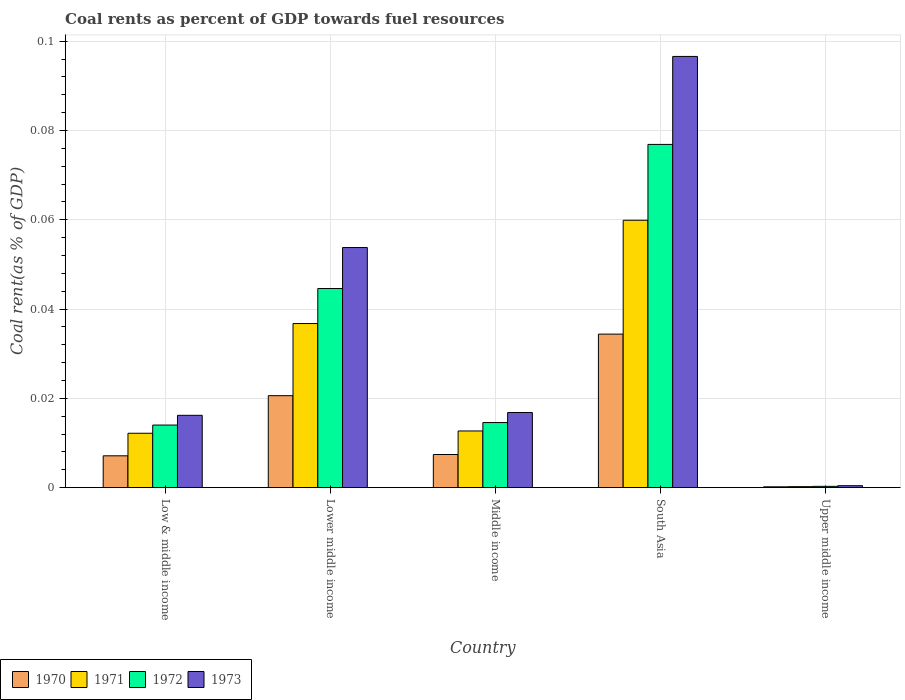How many different coloured bars are there?
Make the answer very short. 4. How many groups of bars are there?
Keep it short and to the point. 5. Are the number of bars on each tick of the X-axis equal?
Keep it short and to the point. Yes. How many bars are there on the 5th tick from the left?
Your answer should be very brief. 4. What is the label of the 5th group of bars from the left?
Keep it short and to the point. Upper middle income. What is the coal rent in 1972 in Middle income?
Ensure brevity in your answer.  0.01. Across all countries, what is the maximum coal rent in 1971?
Your response must be concise. 0.06. Across all countries, what is the minimum coal rent in 1973?
Provide a short and direct response. 0. In which country was the coal rent in 1972 maximum?
Provide a succinct answer. South Asia. In which country was the coal rent in 1970 minimum?
Keep it short and to the point. Upper middle income. What is the total coal rent in 1973 in the graph?
Your answer should be very brief. 0.18. What is the difference between the coal rent in 1971 in Low & middle income and that in Lower middle income?
Your response must be concise. -0.02. What is the difference between the coal rent in 1973 in Low & middle income and the coal rent in 1970 in Upper middle income?
Your answer should be very brief. 0.02. What is the average coal rent in 1972 per country?
Give a very brief answer. 0.03. What is the difference between the coal rent of/in 1970 and coal rent of/in 1973 in Lower middle income?
Provide a short and direct response. -0.03. In how many countries, is the coal rent in 1972 greater than 0.068 %?
Ensure brevity in your answer.  1. What is the ratio of the coal rent in 1970 in Low & middle income to that in South Asia?
Offer a very short reply. 0.21. Is the coal rent in 1971 in Middle income less than that in Upper middle income?
Offer a very short reply. No. What is the difference between the highest and the second highest coal rent in 1971?
Your answer should be very brief. 0.05. What is the difference between the highest and the lowest coal rent in 1973?
Give a very brief answer. 0.1. In how many countries, is the coal rent in 1970 greater than the average coal rent in 1970 taken over all countries?
Offer a terse response. 2. Is the sum of the coal rent in 1970 in Low & middle income and Middle income greater than the maximum coal rent in 1972 across all countries?
Provide a succinct answer. No. Is it the case that in every country, the sum of the coal rent in 1971 and coal rent in 1970 is greater than the sum of coal rent in 1972 and coal rent in 1973?
Provide a succinct answer. No. What does the 4th bar from the left in South Asia represents?
Provide a succinct answer. 1973. What does the 4th bar from the right in Upper middle income represents?
Your answer should be compact. 1970. Is it the case that in every country, the sum of the coal rent in 1971 and coal rent in 1973 is greater than the coal rent in 1972?
Give a very brief answer. Yes. How many bars are there?
Your response must be concise. 20. How many countries are there in the graph?
Keep it short and to the point. 5. Does the graph contain any zero values?
Give a very brief answer. No. Does the graph contain grids?
Offer a very short reply. Yes. Where does the legend appear in the graph?
Provide a short and direct response. Bottom left. How many legend labels are there?
Your response must be concise. 4. What is the title of the graph?
Ensure brevity in your answer.  Coal rents as percent of GDP towards fuel resources. Does "1977" appear as one of the legend labels in the graph?
Offer a terse response. No. What is the label or title of the X-axis?
Provide a short and direct response. Country. What is the label or title of the Y-axis?
Give a very brief answer. Coal rent(as % of GDP). What is the Coal rent(as % of GDP) in 1970 in Low & middle income?
Your answer should be very brief. 0.01. What is the Coal rent(as % of GDP) of 1971 in Low & middle income?
Offer a very short reply. 0.01. What is the Coal rent(as % of GDP) in 1972 in Low & middle income?
Offer a very short reply. 0.01. What is the Coal rent(as % of GDP) in 1973 in Low & middle income?
Offer a terse response. 0.02. What is the Coal rent(as % of GDP) in 1970 in Lower middle income?
Give a very brief answer. 0.02. What is the Coal rent(as % of GDP) of 1971 in Lower middle income?
Your response must be concise. 0.04. What is the Coal rent(as % of GDP) of 1972 in Lower middle income?
Ensure brevity in your answer.  0.04. What is the Coal rent(as % of GDP) in 1973 in Lower middle income?
Keep it short and to the point. 0.05. What is the Coal rent(as % of GDP) in 1970 in Middle income?
Offer a very short reply. 0.01. What is the Coal rent(as % of GDP) in 1971 in Middle income?
Give a very brief answer. 0.01. What is the Coal rent(as % of GDP) in 1972 in Middle income?
Provide a short and direct response. 0.01. What is the Coal rent(as % of GDP) in 1973 in Middle income?
Provide a short and direct response. 0.02. What is the Coal rent(as % of GDP) in 1970 in South Asia?
Give a very brief answer. 0.03. What is the Coal rent(as % of GDP) of 1971 in South Asia?
Provide a short and direct response. 0.06. What is the Coal rent(as % of GDP) of 1972 in South Asia?
Offer a terse response. 0.08. What is the Coal rent(as % of GDP) of 1973 in South Asia?
Your response must be concise. 0.1. What is the Coal rent(as % of GDP) of 1970 in Upper middle income?
Your response must be concise. 0. What is the Coal rent(as % of GDP) of 1971 in Upper middle income?
Your answer should be very brief. 0. What is the Coal rent(as % of GDP) in 1972 in Upper middle income?
Your answer should be very brief. 0. What is the Coal rent(as % of GDP) of 1973 in Upper middle income?
Make the answer very short. 0. Across all countries, what is the maximum Coal rent(as % of GDP) in 1970?
Provide a succinct answer. 0.03. Across all countries, what is the maximum Coal rent(as % of GDP) in 1971?
Your answer should be compact. 0.06. Across all countries, what is the maximum Coal rent(as % of GDP) of 1972?
Offer a very short reply. 0.08. Across all countries, what is the maximum Coal rent(as % of GDP) of 1973?
Your answer should be compact. 0.1. Across all countries, what is the minimum Coal rent(as % of GDP) in 1970?
Provide a succinct answer. 0. Across all countries, what is the minimum Coal rent(as % of GDP) of 1971?
Make the answer very short. 0. Across all countries, what is the minimum Coal rent(as % of GDP) of 1972?
Keep it short and to the point. 0. Across all countries, what is the minimum Coal rent(as % of GDP) in 1973?
Your response must be concise. 0. What is the total Coal rent(as % of GDP) of 1970 in the graph?
Offer a terse response. 0.07. What is the total Coal rent(as % of GDP) of 1971 in the graph?
Ensure brevity in your answer.  0.12. What is the total Coal rent(as % of GDP) of 1972 in the graph?
Give a very brief answer. 0.15. What is the total Coal rent(as % of GDP) of 1973 in the graph?
Provide a succinct answer. 0.18. What is the difference between the Coal rent(as % of GDP) in 1970 in Low & middle income and that in Lower middle income?
Provide a short and direct response. -0.01. What is the difference between the Coal rent(as % of GDP) in 1971 in Low & middle income and that in Lower middle income?
Provide a succinct answer. -0.02. What is the difference between the Coal rent(as % of GDP) of 1972 in Low & middle income and that in Lower middle income?
Provide a short and direct response. -0.03. What is the difference between the Coal rent(as % of GDP) in 1973 in Low & middle income and that in Lower middle income?
Offer a very short reply. -0.04. What is the difference between the Coal rent(as % of GDP) of 1970 in Low & middle income and that in Middle income?
Make the answer very short. -0. What is the difference between the Coal rent(as % of GDP) in 1971 in Low & middle income and that in Middle income?
Provide a succinct answer. -0. What is the difference between the Coal rent(as % of GDP) in 1972 in Low & middle income and that in Middle income?
Offer a terse response. -0. What is the difference between the Coal rent(as % of GDP) of 1973 in Low & middle income and that in Middle income?
Provide a short and direct response. -0. What is the difference between the Coal rent(as % of GDP) of 1970 in Low & middle income and that in South Asia?
Offer a very short reply. -0.03. What is the difference between the Coal rent(as % of GDP) in 1971 in Low & middle income and that in South Asia?
Keep it short and to the point. -0.05. What is the difference between the Coal rent(as % of GDP) in 1972 in Low & middle income and that in South Asia?
Your answer should be compact. -0.06. What is the difference between the Coal rent(as % of GDP) of 1973 in Low & middle income and that in South Asia?
Ensure brevity in your answer.  -0.08. What is the difference between the Coal rent(as % of GDP) of 1970 in Low & middle income and that in Upper middle income?
Make the answer very short. 0.01. What is the difference between the Coal rent(as % of GDP) of 1971 in Low & middle income and that in Upper middle income?
Make the answer very short. 0.01. What is the difference between the Coal rent(as % of GDP) in 1972 in Low & middle income and that in Upper middle income?
Ensure brevity in your answer.  0.01. What is the difference between the Coal rent(as % of GDP) in 1973 in Low & middle income and that in Upper middle income?
Offer a very short reply. 0.02. What is the difference between the Coal rent(as % of GDP) in 1970 in Lower middle income and that in Middle income?
Make the answer very short. 0.01. What is the difference between the Coal rent(as % of GDP) in 1971 in Lower middle income and that in Middle income?
Your answer should be compact. 0.02. What is the difference between the Coal rent(as % of GDP) of 1972 in Lower middle income and that in Middle income?
Your answer should be very brief. 0.03. What is the difference between the Coal rent(as % of GDP) of 1973 in Lower middle income and that in Middle income?
Your answer should be very brief. 0.04. What is the difference between the Coal rent(as % of GDP) of 1970 in Lower middle income and that in South Asia?
Keep it short and to the point. -0.01. What is the difference between the Coal rent(as % of GDP) of 1971 in Lower middle income and that in South Asia?
Make the answer very short. -0.02. What is the difference between the Coal rent(as % of GDP) in 1972 in Lower middle income and that in South Asia?
Provide a succinct answer. -0.03. What is the difference between the Coal rent(as % of GDP) in 1973 in Lower middle income and that in South Asia?
Your response must be concise. -0.04. What is the difference between the Coal rent(as % of GDP) of 1970 in Lower middle income and that in Upper middle income?
Ensure brevity in your answer.  0.02. What is the difference between the Coal rent(as % of GDP) in 1971 in Lower middle income and that in Upper middle income?
Give a very brief answer. 0.04. What is the difference between the Coal rent(as % of GDP) of 1972 in Lower middle income and that in Upper middle income?
Ensure brevity in your answer.  0.04. What is the difference between the Coal rent(as % of GDP) in 1973 in Lower middle income and that in Upper middle income?
Your answer should be compact. 0.05. What is the difference between the Coal rent(as % of GDP) of 1970 in Middle income and that in South Asia?
Provide a short and direct response. -0.03. What is the difference between the Coal rent(as % of GDP) of 1971 in Middle income and that in South Asia?
Your response must be concise. -0.05. What is the difference between the Coal rent(as % of GDP) in 1972 in Middle income and that in South Asia?
Provide a short and direct response. -0.06. What is the difference between the Coal rent(as % of GDP) of 1973 in Middle income and that in South Asia?
Give a very brief answer. -0.08. What is the difference between the Coal rent(as % of GDP) of 1970 in Middle income and that in Upper middle income?
Offer a very short reply. 0.01. What is the difference between the Coal rent(as % of GDP) of 1971 in Middle income and that in Upper middle income?
Your answer should be very brief. 0.01. What is the difference between the Coal rent(as % of GDP) in 1972 in Middle income and that in Upper middle income?
Offer a terse response. 0.01. What is the difference between the Coal rent(as % of GDP) of 1973 in Middle income and that in Upper middle income?
Make the answer very short. 0.02. What is the difference between the Coal rent(as % of GDP) in 1970 in South Asia and that in Upper middle income?
Offer a terse response. 0.03. What is the difference between the Coal rent(as % of GDP) of 1971 in South Asia and that in Upper middle income?
Make the answer very short. 0.06. What is the difference between the Coal rent(as % of GDP) of 1972 in South Asia and that in Upper middle income?
Your response must be concise. 0.08. What is the difference between the Coal rent(as % of GDP) in 1973 in South Asia and that in Upper middle income?
Provide a short and direct response. 0.1. What is the difference between the Coal rent(as % of GDP) in 1970 in Low & middle income and the Coal rent(as % of GDP) in 1971 in Lower middle income?
Provide a succinct answer. -0.03. What is the difference between the Coal rent(as % of GDP) of 1970 in Low & middle income and the Coal rent(as % of GDP) of 1972 in Lower middle income?
Give a very brief answer. -0.04. What is the difference between the Coal rent(as % of GDP) of 1970 in Low & middle income and the Coal rent(as % of GDP) of 1973 in Lower middle income?
Keep it short and to the point. -0.05. What is the difference between the Coal rent(as % of GDP) of 1971 in Low & middle income and the Coal rent(as % of GDP) of 1972 in Lower middle income?
Your answer should be very brief. -0.03. What is the difference between the Coal rent(as % of GDP) of 1971 in Low & middle income and the Coal rent(as % of GDP) of 1973 in Lower middle income?
Provide a succinct answer. -0.04. What is the difference between the Coal rent(as % of GDP) of 1972 in Low & middle income and the Coal rent(as % of GDP) of 1973 in Lower middle income?
Your response must be concise. -0.04. What is the difference between the Coal rent(as % of GDP) in 1970 in Low & middle income and the Coal rent(as % of GDP) in 1971 in Middle income?
Provide a short and direct response. -0.01. What is the difference between the Coal rent(as % of GDP) in 1970 in Low & middle income and the Coal rent(as % of GDP) in 1972 in Middle income?
Offer a very short reply. -0.01. What is the difference between the Coal rent(as % of GDP) of 1970 in Low & middle income and the Coal rent(as % of GDP) of 1973 in Middle income?
Your answer should be compact. -0.01. What is the difference between the Coal rent(as % of GDP) of 1971 in Low & middle income and the Coal rent(as % of GDP) of 1972 in Middle income?
Keep it short and to the point. -0. What is the difference between the Coal rent(as % of GDP) of 1971 in Low & middle income and the Coal rent(as % of GDP) of 1973 in Middle income?
Give a very brief answer. -0. What is the difference between the Coal rent(as % of GDP) of 1972 in Low & middle income and the Coal rent(as % of GDP) of 1973 in Middle income?
Your answer should be very brief. -0. What is the difference between the Coal rent(as % of GDP) of 1970 in Low & middle income and the Coal rent(as % of GDP) of 1971 in South Asia?
Make the answer very short. -0.05. What is the difference between the Coal rent(as % of GDP) of 1970 in Low & middle income and the Coal rent(as % of GDP) of 1972 in South Asia?
Give a very brief answer. -0.07. What is the difference between the Coal rent(as % of GDP) of 1970 in Low & middle income and the Coal rent(as % of GDP) of 1973 in South Asia?
Your answer should be very brief. -0.09. What is the difference between the Coal rent(as % of GDP) in 1971 in Low & middle income and the Coal rent(as % of GDP) in 1972 in South Asia?
Make the answer very short. -0.06. What is the difference between the Coal rent(as % of GDP) in 1971 in Low & middle income and the Coal rent(as % of GDP) in 1973 in South Asia?
Your response must be concise. -0.08. What is the difference between the Coal rent(as % of GDP) in 1972 in Low & middle income and the Coal rent(as % of GDP) in 1973 in South Asia?
Your response must be concise. -0.08. What is the difference between the Coal rent(as % of GDP) in 1970 in Low & middle income and the Coal rent(as % of GDP) in 1971 in Upper middle income?
Keep it short and to the point. 0.01. What is the difference between the Coal rent(as % of GDP) in 1970 in Low & middle income and the Coal rent(as % of GDP) in 1972 in Upper middle income?
Ensure brevity in your answer.  0.01. What is the difference between the Coal rent(as % of GDP) of 1970 in Low & middle income and the Coal rent(as % of GDP) of 1973 in Upper middle income?
Your answer should be very brief. 0.01. What is the difference between the Coal rent(as % of GDP) in 1971 in Low & middle income and the Coal rent(as % of GDP) in 1972 in Upper middle income?
Ensure brevity in your answer.  0.01. What is the difference between the Coal rent(as % of GDP) in 1971 in Low & middle income and the Coal rent(as % of GDP) in 1973 in Upper middle income?
Offer a very short reply. 0.01. What is the difference between the Coal rent(as % of GDP) in 1972 in Low & middle income and the Coal rent(as % of GDP) in 1973 in Upper middle income?
Ensure brevity in your answer.  0.01. What is the difference between the Coal rent(as % of GDP) of 1970 in Lower middle income and the Coal rent(as % of GDP) of 1971 in Middle income?
Your answer should be very brief. 0.01. What is the difference between the Coal rent(as % of GDP) of 1970 in Lower middle income and the Coal rent(as % of GDP) of 1972 in Middle income?
Your answer should be very brief. 0.01. What is the difference between the Coal rent(as % of GDP) of 1970 in Lower middle income and the Coal rent(as % of GDP) of 1973 in Middle income?
Provide a short and direct response. 0. What is the difference between the Coal rent(as % of GDP) of 1971 in Lower middle income and the Coal rent(as % of GDP) of 1972 in Middle income?
Your answer should be compact. 0.02. What is the difference between the Coal rent(as % of GDP) in 1971 in Lower middle income and the Coal rent(as % of GDP) in 1973 in Middle income?
Your answer should be compact. 0.02. What is the difference between the Coal rent(as % of GDP) of 1972 in Lower middle income and the Coal rent(as % of GDP) of 1973 in Middle income?
Offer a terse response. 0.03. What is the difference between the Coal rent(as % of GDP) of 1970 in Lower middle income and the Coal rent(as % of GDP) of 1971 in South Asia?
Offer a very short reply. -0.04. What is the difference between the Coal rent(as % of GDP) in 1970 in Lower middle income and the Coal rent(as % of GDP) in 1972 in South Asia?
Make the answer very short. -0.06. What is the difference between the Coal rent(as % of GDP) in 1970 in Lower middle income and the Coal rent(as % of GDP) in 1973 in South Asia?
Your answer should be compact. -0.08. What is the difference between the Coal rent(as % of GDP) of 1971 in Lower middle income and the Coal rent(as % of GDP) of 1972 in South Asia?
Ensure brevity in your answer.  -0.04. What is the difference between the Coal rent(as % of GDP) of 1971 in Lower middle income and the Coal rent(as % of GDP) of 1973 in South Asia?
Provide a short and direct response. -0.06. What is the difference between the Coal rent(as % of GDP) in 1972 in Lower middle income and the Coal rent(as % of GDP) in 1973 in South Asia?
Give a very brief answer. -0.05. What is the difference between the Coal rent(as % of GDP) of 1970 in Lower middle income and the Coal rent(as % of GDP) of 1971 in Upper middle income?
Your answer should be compact. 0.02. What is the difference between the Coal rent(as % of GDP) in 1970 in Lower middle income and the Coal rent(as % of GDP) in 1972 in Upper middle income?
Your response must be concise. 0.02. What is the difference between the Coal rent(as % of GDP) in 1970 in Lower middle income and the Coal rent(as % of GDP) in 1973 in Upper middle income?
Your answer should be compact. 0.02. What is the difference between the Coal rent(as % of GDP) of 1971 in Lower middle income and the Coal rent(as % of GDP) of 1972 in Upper middle income?
Keep it short and to the point. 0.04. What is the difference between the Coal rent(as % of GDP) in 1971 in Lower middle income and the Coal rent(as % of GDP) in 1973 in Upper middle income?
Provide a short and direct response. 0.04. What is the difference between the Coal rent(as % of GDP) of 1972 in Lower middle income and the Coal rent(as % of GDP) of 1973 in Upper middle income?
Your response must be concise. 0.04. What is the difference between the Coal rent(as % of GDP) of 1970 in Middle income and the Coal rent(as % of GDP) of 1971 in South Asia?
Offer a very short reply. -0.05. What is the difference between the Coal rent(as % of GDP) of 1970 in Middle income and the Coal rent(as % of GDP) of 1972 in South Asia?
Your answer should be compact. -0.07. What is the difference between the Coal rent(as % of GDP) in 1970 in Middle income and the Coal rent(as % of GDP) in 1973 in South Asia?
Your answer should be compact. -0.09. What is the difference between the Coal rent(as % of GDP) in 1971 in Middle income and the Coal rent(as % of GDP) in 1972 in South Asia?
Offer a terse response. -0.06. What is the difference between the Coal rent(as % of GDP) of 1971 in Middle income and the Coal rent(as % of GDP) of 1973 in South Asia?
Provide a succinct answer. -0.08. What is the difference between the Coal rent(as % of GDP) in 1972 in Middle income and the Coal rent(as % of GDP) in 1973 in South Asia?
Make the answer very short. -0.08. What is the difference between the Coal rent(as % of GDP) of 1970 in Middle income and the Coal rent(as % of GDP) of 1971 in Upper middle income?
Provide a short and direct response. 0.01. What is the difference between the Coal rent(as % of GDP) of 1970 in Middle income and the Coal rent(as % of GDP) of 1972 in Upper middle income?
Keep it short and to the point. 0.01. What is the difference between the Coal rent(as % of GDP) in 1970 in Middle income and the Coal rent(as % of GDP) in 1973 in Upper middle income?
Provide a succinct answer. 0.01. What is the difference between the Coal rent(as % of GDP) of 1971 in Middle income and the Coal rent(as % of GDP) of 1972 in Upper middle income?
Your response must be concise. 0.01. What is the difference between the Coal rent(as % of GDP) of 1971 in Middle income and the Coal rent(as % of GDP) of 1973 in Upper middle income?
Your response must be concise. 0.01. What is the difference between the Coal rent(as % of GDP) of 1972 in Middle income and the Coal rent(as % of GDP) of 1973 in Upper middle income?
Provide a succinct answer. 0.01. What is the difference between the Coal rent(as % of GDP) of 1970 in South Asia and the Coal rent(as % of GDP) of 1971 in Upper middle income?
Provide a succinct answer. 0.03. What is the difference between the Coal rent(as % of GDP) of 1970 in South Asia and the Coal rent(as % of GDP) of 1972 in Upper middle income?
Keep it short and to the point. 0.03. What is the difference between the Coal rent(as % of GDP) in 1970 in South Asia and the Coal rent(as % of GDP) in 1973 in Upper middle income?
Your answer should be very brief. 0.03. What is the difference between the Coal rent(as % of GDP) of 1971 in South Asia and the Coal rent(as % of GDP) of 1972 in Upper middle income?
Your answer should be very brief. 0.06. What is the difference between the Coal rent(as % of GDP) of 1971 in South Asia and the Coal rent(as % of GDP) of 1973 in Upper middle income?
Keep it short and to the point. 0.06. What is the difference between the Coal rent(as % of GDP) of 1972 in South Asia and the Coal rent(as % of GDP) of 1973 in Upper middle income?
Your response must be concise. 0.08. What is the average Coal rent(as % of GDP) of 1970 per country?
Your response must be concise. 0.01. What is the average Coal rent(as % of GDP) of 1971 per country?
Give a very brief answer. 0.02. What is the average Coal rent(as % of GDP) of 1972 per country?
Make the answer very short. 0.03. What is the average Coal rent(as % of GDP) in 1973 per country?
Your answer should be very brief. 0.04. What is the difference between the Coal rent(as % of GDP) of 1970 and Coal rent(as % of GDP) of 1971 in Low & middle income?
Ensure brevity in your answer.  -0.01. What is the difference between the Coal rent(as % of GDP) in 1970 and Coal rent(as % of GDP) in 1972 in Low & middle income?
Give a very brief answer. -0.01. What is the difference between the Coal rent(as % of GDP) of 1970 and Coal rent(as % of GDP) of 1973 in Low & middle income?
Provide a short and direct response. -0.01. What is the difference between the Coal rent(as % of GDP) of 1971 and Coal rent(as % of GDP) of 1972 in Low & middle income?
Offer a very short reply. -0. What is the difference between the Coal rent(as % of GDP) of 1971 and Coal rent(as % of GDP) of 1973 in Low & middle income?
Ensure brevity in your answer.  -0. What is the difference between the Coal rent(as % of GDP) of 1972 and Coal rent(as % of GDP) of 1973 in Low & middle income?
Your response must be concise. -0. What is the difference between the Coal rent(as % of GDP) of 1970 and Coal rent(as % of GDP) of 1971 in Lower middle income?
Provide a short and direct response. -0.02. What is the difference between the Coal rent(as % of GDP) in 1970 and Coal rent(as % of GDP) in 1972 in Lower middle income?
Offer a very short reply. -0.02. What is the difference between the Coal rent(as % of GDP) of 1970 and Coal rent(as % of GDP) of 1973 in Lower middle income?
Offer a very short reply. -0.03. What is the difference between the Coal rent(as % of GDP) of 1971 and Coal rent(as % of GDP) of 1972 in Lower middle income?
Provide a short and direct response. -0.01. What is the difference between the Coal rent(as % of GDP) in 1971 and Coal rent(as % of GDP) in 1973 in Lower middle income?
Give a very brief answer. -0.02. What is the difference between the Coal rent(as % of GDP) of 1972 and Coal rent(as % of GDP) of 1973 in Lower middle income?
Ensure brevity in your answer.  -0.01. What is the difference between the Coal rent(as % of GDP) of 1970 and Coal rent(as % of GDP) of 1971 in Middle income?
Offer a terse response. -0.01. What is the difference between the Coal rent(as % of GDP) in 1970 and Coal rent(as % of GDP) in 1972 in Middle income?
Provide a short and direct response. -0.01. What is the difference between the Coal rent(as % of GDP) in 1970 and Coal rent(as % of GDP) in 1973 in Middle income?
Offer a terse response. -0.01. What is the difference between the Coal rent(as % of GDP) of 1971 and Coal rent(as % of GDP) of 1972 in Middle income?
Make the answer very short. -0. What is the difference between the Coal rent(as % of GDP) of 1971 and Coal rent(as % of GDP) of 1973 in Middle income?
Offer a terse response. -0. What is the difference between the Coal rent(as % of GDP) in 1972 and Coal rent(as % of GDP) in 1973 in Middle income?
Offer a terse response. -0. What is the difference between the Coal rent(as % of GDP) of 1970 and Coal rent(as % of GDP) of 1971 in South Asia?
Your answer should be compact. -0.03. What is the difference between the Coal rent(as % of GDP) in 1970 and Coal rent(as % of GDP) in 1972 in South Asia?
Your answer should be very brief. -0.04. What is the difference between the Coal rent(as % of GDP) of 1970 and Coal rent(as % of GDP) of 1973 in South Asia?
Offer a terse response. -0.06. What is the difference between the Coal rent(as % of GDP) of 1971 and Coal rent(as % of GDP) of 1972 in South Asia?
Make the answer very short. -0.02. What is the difference between the Coal rent(as % of GDP) of 1971 and Coal rent(as % of GDP) of 1973 in South Asia?
Offer a very short reply. -0.04. What is the difference between the Coal rent(as % of GDP) of 1972 and Coal rent(as % of GDP) of 1973 in South Asia?
Offer a very short reply. -0.02. What is the difference between the Coal rent(as % of GDP) in 1970 and Coal rent(as % of GDP) in 1971 in Upper middle income?
Your response must be concise. -0. What is the difference between the Coal rent(as % of GDP) in 1970 and Coal rent(as % of GDP) in 1972 in Upper middle income?
Provide a succinct answer. -0. What is the difference between the Coal rent(as % of GDP) in 1970 and Coal rent(as % of GDP) in 1973 in Upper middle income?
Offer a terse response. -0. What is the difference between the Coal rent(as % of GDP) in 1971 and Coal rent(as % of GDP) in 1972 in Upper middle income?
Keep it short and to the point. -0. What is the difference between the Coal rent(as % of GDP) of 1971 and Coal rent(as % of GDP) of 1973 in Upper middle income?
Ensure brevity in your answer.  -0. What is the difference between the Coal rent(as % of GDP) of 1972 and Coal rent(as % of GDP) of 1973 in Upper middle income?
Offer a very short reply. -0. What is the ratio of the Coal rent(as % of GDP) of 1970 in Low & middle income to that in Lower middle income?
Offer a very short reply. 0.35. What is the ratio of the Coal rent(as % of GDP) in 1971 in Low & middle income to that in Lower middle income?
Ensure brevity in your answer.  0.33. What is the ratio of the Coal rent(as % of GDP) in 1972 in Low & middle income to that in Lower middle income?
Provide a short and direct response. 0.31. What is the ratio of the Coal rent(as % of GDP) in 1973 in Low & middle income to that in Lower middle income?
Ensure brevity in your answer.  0.3. What is the ratio of the Coal rent(as % of GDP) in 1970 in Low & middle income to that in Middle income?
Your answer should be very brief. 0.96. What is the ratio of the Coal rent(as % of GDP) in 1971 in Low & middle income to that in Middle income?
Make the answer very short. 0.96. What is the ratio of the Coal rent(as % of GDP) of 1972 in Low & middle income to that in Middle income?
Your response must be concise. 0.96. What is the ratio of the Coal rent(as % of GDP) in 1973 in Low & middle income to that in Middle income?
Your answer should be very brief. 0.96. What is the ratio of the Coal rent(as % of GDP) of 1970 in Low & middle income to that in South Asia?
Make the answer very short. 0.21. What is the ratio of the Coal rent(as % of GDP) of 1971 in Low & middle income to that in South Asia?
Offer a very short reply. 0.2. What is the ratio of the Coal rent(as % of GDP) in 1972 in Low & middle income to that in South Asia?
Your answer should be very brief. 0.18. What is the ratio of the Coal rent(as % of GDP) in 1973 in Low & middle income to that in South Asia?
Keep it short and to the point. 0.17. What is the ratio of the Coal rent(as % of GDP) of 1970 in Low & middle income to that in Upper middle income?
Your response must be concise. 38.77. What is the ratio of the Coal rent(as % of GDP) of 1971 in Low & middle income to that in Upper middle income?
Give a very brief answer. 55.66. What is the ratio of the Coal rent(as % of GDP) in 1972 in Low & middle income to that in Upper middle income?
Your answer should be very brief. 49.28. What is the ratio of the Coal rent(as % of GDP) in 1973 in Low & middle income to that in Upper middle income?
Your answer should be compact. 37.59. What is the ratio of the Coal rent(as % of GDP) in 1970 in Lower middle income to that in Middle income?
Your response must be concise. 2.78. What is the ratio of the Coal rent(as % of GDP) of 1971 in Lower middle income to that in Middle income?
Your answer should be very brief. 2.9. What is the ratio of the Coal rent(as % of GDP) of 1972 in Lower middle income to that in Middle income?
Offer a very short reply. 3.06. What is the ratio of the Coal rent(as % of GDP) in 1973 in Lower middle income to that in Middle income?
Give a very brief answer. 3.2. What is the ratio of the Coal rent(as % of GDP) of 1970 in Lower middle income to that in South Asia?
Your response must be concise. 0.6. What is the ratio of the Coal rent(as % of GDP) in 1971 in Lower middle income to that in South Asia?
Provide a succinct answer. 0.61. What is the ratio of the Coal rent(as % of GDP) in 1972 in Lower middle income to that in South Asia?
Offer a very short reply. 0.58. What is the ratio of the Coal rent(as % of GDP) in 1973 in Lower middle income to that in South Asia?
Offer a terse response. 0.56. What is the ratio of the Coal rent(as % of GDP) in 1970 in Lower middle income to that in Upper middle income?
Offer a terse response. 112.03. What is the ratio of the Coal rent(as % of GDP) in 1971 in Lower middle income to that in Upper middle income?
Offer a terse response. 167.98. What is the ratio of the Coal rent(as % of GDP) of 1972 in Lower middle income to that in Upper middle income?
Make the answer very short. 156.82. What is the ratio of the Coal rent(as % of GDP) of 1973 in Lower middle income to that in Upper middle income?
Give a very brief answer. 124.82. What is the ratio of the Coal rent(as % of GDP) in 1970 in Middle income to that in South Asia?
Your answer should be compact. 0.22. What is the ratio of the Coal rent(as % of GDP) of 1971 in Middle income to that in South Asia?
Your response must be concise. 0.21. What is the ratio of the Coal rent(as % of GDP) in 1972 in Middle income to that in South Asia?
Your answer should be very brief. 0.19. What is the ratio of the Coal rent(as % of GDP) in 1973 in Middle income to that in South Asia?
Give a very brief answer. 0.17. What is the ratio of the Coal rent(as % of GDP) of 1970 in Middle income to that in Upper middle income?
Your answer should be very brief. 40.36. What is the ratio of the Coal rent(as % of GDP) in 1971 in Middle income to that in Upper middle income?
Your answer should be compact. 58.01. What is the ratio of the Coal rent(as % of GDP) of 1972 in Middle income to that in Upper middle income?
Provide a short and direct response. 51.25. What is the ratio of the Coal rent(as % of GDP) in 1973 in Middle income to that in Upper middle income?
Give a very brief answer. 39.04. What is the ratio of the Coal rent(as % of GDP) of 1970 in South Asia to that in Upper middle income?
Your response must be concise. 187.05. What is the ratio of the Coal rent(as % of GDP) in 1971 in South Asia to that in Upper middle income?
Keep it short and to the point. 273.74. What is the ratio of the Coal rent(as % of GDP) of 1972 in South Asia to that in Upper middle income?
Provide a short and direct response. 270.32. What is the ratio of the Coal rent(as % of GDP) of 1973 in South Asia to that in Upper middle income?
Ensure brevity in your answer.  224.18. What is the difference between the highest and the second highest Coal rent(as % of GDP) in 1970?
Make the answer very short. 0.01. What is the difference between the highest and the second highest Coal rent(as % of GDP) of 1971?
Your answer should be compact. 0.02. What is the difference between the highest and the second highest Coal rent(as % of GDP) of 1972?
Your response must be concise. 0.03. What is the difference between the highest and the second highest Coal rent(as % of GDP) of 1973?
Make the answer very short. 0.04. What is the difference between the highest and the lowest Coal rent(as % of GDP) in 1970?
Make the answer very short. 0.03. What is the difference between the highest and the lowest Coal rent(as % of GDP) in 1971?
Make the answer very short. 0.06. What is the difference between the highest and the lowest Coal rent(as % of GDP) of 1972?
Your answer should be compact. 0.08. What is the difference between the highest and the lowest Coal rent(as % of GDP) in 1973?
Keep it short and to the point. 0.1. 